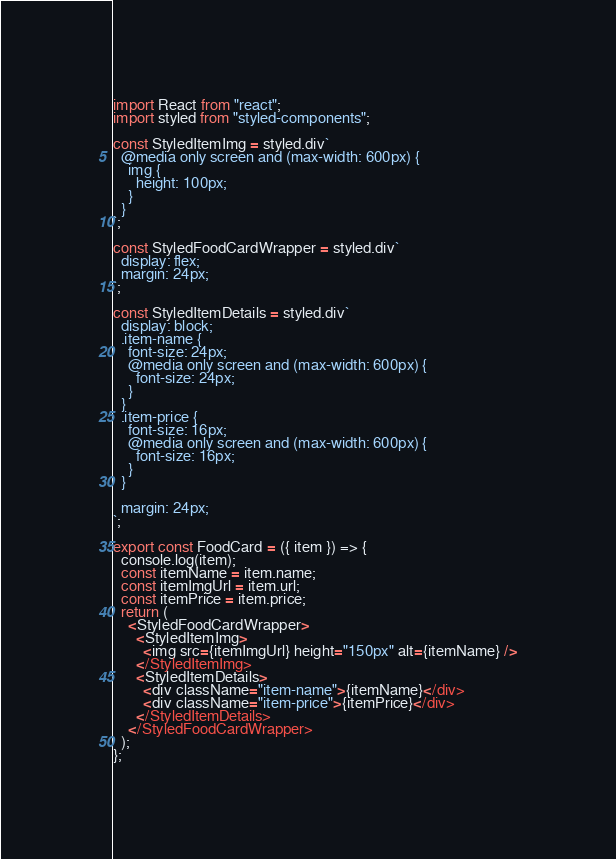<code> <loc_0><loc_0><loc_500><loc_500><_JavaScript_>import React from "react";
import styled from "styled-components";

const StyledItemImg = styled.div`
  @media only screen and (max-width: 600px) {
    img {
      height: 100px;
    }
  }
`;

const StyledFoodCardWrapper = styled.div`
  display: flex;
  margin: 24px;
`;

const StyledItemDetails = styled.div`
  display: block;
  .item-name {
    font-size: 24px;
    @media only screen and (max-width: 600px) {
      font-size: 24px;
    }
  }
  .item-price {
    font-size: 16px;
    @media only screen and (max-width: 600px) {
      font-size: 16px;
    }
  }

  margin: 24px;
`;

export const FoodCard = ({ item }) => {
  console.log(item);
  const itemName = item.name;
  const itemImgUrl = item.url;
  const itemPrice = item.price;
  return (
    <StyledFoodCardWrapper>
      <StyledItemImg>
        <img src={itemImgUrl} height="150px" alt={itemName} />
      </StyledItemImg>
      <StyledItemDetails>
        <div className="item-name">{itemName}</div>
        <div className="item-price">{itemPrice}</div>
      </StyledItemDetails>
    </StyledFoodCardWrapper>
  );
};
</code> 